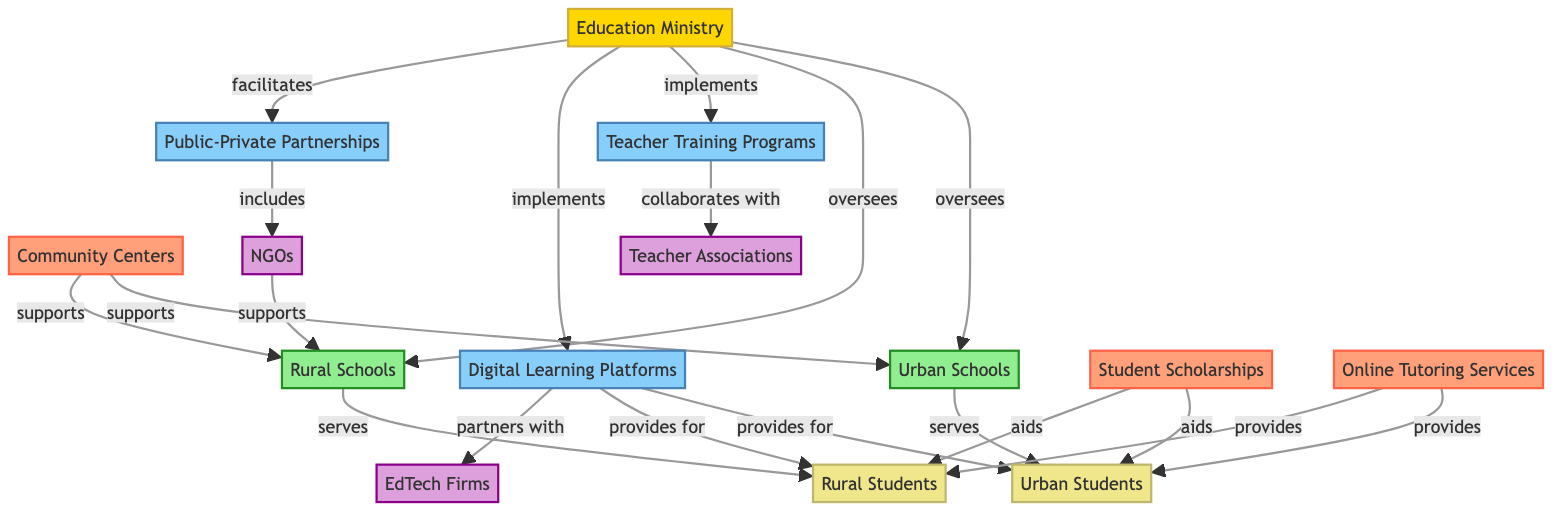What is the total number of nodes in the diagram? The diagram contains 14 different nodes, which are distinct entities either representing locations, initiatives, resources, partners, or the ministry itself. Counting each unique entity gives us the total.
Answer: 14 Which two types of locations are represented in the diagram? The diagram includes two specific types of locations: "Urban Schools" and "Rural Schools." These locations are labeled clearly within the nodes identified in the data provided.
Answer: Urban Schools, Rural Schools Who collaborates with Teacher Training Programs? The "Teacher Associations" node is directly connected to "Teacher Training Programs" with a "collaborates with" relationship, indicating that they work together. This is a straightforward connection visible in the diagram.
Answer: Teacher Associations How many initiatives are implemented by the Education Ministry? The Education Ministry implements two initiatives as indicated by the direct relationships: "Teacher Training Programs" and "Digital Learning Platforms." Counting these yields the total number of initiatives implemented.
Answer: 2 What type of resources aid both Urban and Rural Students? The resources "Student Scholarships" and "Online Tutoring Services" aid both "Urban Students" and "Rural Students," which are connected by "aids" relationships in the diagram. Examining these connections reveals this information.
Answer: Student Scholarships, Online Tutoring Services What type of partnership includes NGOs? The "Public-Private Partnerships" initiative includes "NGOs," as indicated by the diagram. The direct relationship demonstrates their involvement in this partnership, revealing how each plays a role in reaching educational goals.
Answer: Public-Private Partnerships Which schools are served by Urban Students? "Urban Schools" directly serves "Urban Students," making it clear that this location provides educational opportunities specifically tailored for urban demographics. The connection in the diagram delineates this relationship clearly.
Answer: Urban Schools Do Digital Learning Platforms provide for both types of students? Yes, "Digital Learning Platforms" provide for both "Urban Students" and "Rural Students," as seen in the respective connections to both student nodes, confirming that the initiative aims to reach a diverse audience.
Answer: Yes 